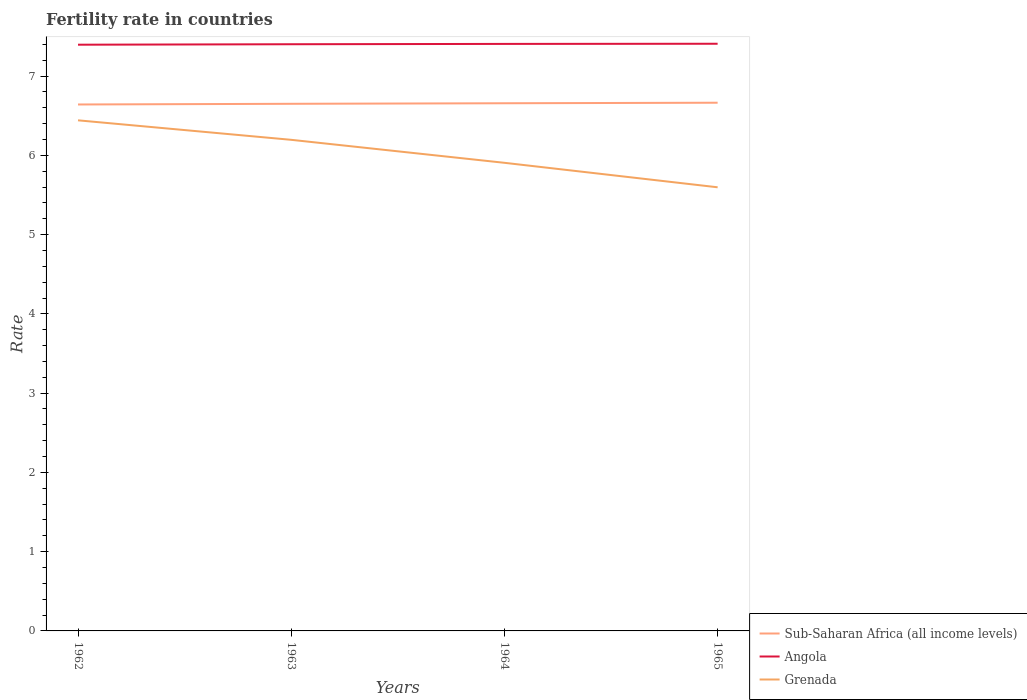Is the number of lines equal to the number of legend labels?
Make the answer very short. Yes. Across all years, what is the maximum fertility rate in Angola?
Offer a terse response. 7.4. In which year was the fertility rate in Angola maximum?
Provide a succinct answer. 1962. What is the total fertility rate in Sub-Saharan Africa (all income levels) in the graph?
Your answer should be compact. -0.01. What is the difference between the highest and the second highest fertility rate in Angola?
Your answer should be compact. 0.01. How many lines are there?
Give a very brief answer. 3. Are the values on the major ticks of Y-axis written in scientific E-notation?
Offer a terse response. No. Where does the legend appear in the graph?
Provide a short and direct response. Bottom right. How many legend labels are there?
Your answer should be compact. 3. How are the legend labels stacked?
Offer a terse response. Vertical. What is the title of the graph?
Give a very brief answer. Fertility rate in countries. Does "Sri Lanka" appear as one of the legend labels in the graph?
Give a very brief answer. No. What is the label or title of the X-axis?
Offer a very short reply. Years. What is the label or title of the Y-axis?
Keep it short and to the point. Rate. What is the Rate in Sub-Saharan Africa (all income levels) in 1962?
Ensure brevity in your answer.  6.64. What is the Rate of Angola in 1962?
Keep it short and to the point. 7.4. What is the Rate of Grenada in 1962?
Keep it short and to the point. 6.44. What is the Rate in Sub-Saharan Africa (all income levels) in 1963?
Provide a succinct answer. 6.65. What is the Rate of Angola in 1963?
Your response must be concise. 7.4. What is the Rate of Grenada in 1963?
Provide a succinct answer. 6.2. What is the Rate in Sub-Saharan Africa (all income levels) in 1964?
Offer a terse response. 6.66. What is the Rate of Angola in 1964?
Keep it short and to the point. 7.41. What is the Rate of Grenada in 1964?
Give a very brief answer. 5.91. What is the Rate in Sub-Saharan Africa (all income levels) in 1965?
Your answer should be very brief. 6.66. What is the Rate in Angola in 1965?
Keep it short and to the point. 7.41. What is the Rate in Grenada in 1965?
Keep it short and to the point. 5.6. Across all years, what is the maximum Rate in Sub-Saharan Africa (all income levels)?
Your answer should be compact. 6.66. Across all years, what is the maximum Rate in Angola?
Provide a short and direct response. 7.41. Across all years, what is the maximum Rate in Grenada?
Your answer should be very brief. 6.44. Across all years, what is the minimum Rate of Sub-Saharan Africa (all income levels)?
Your answer should be compact. 6.64. Across all years, what is the minimum Rate in Angola?
Your response must be concise. 7.4. Across all years, what is the minimum Rate in Grenada?
Your answer should be compact. 5.6. What is the total Rate in Sub-Saharan Africa (all income levels) in the graph?
Your response must be concise. 26.61. What is the total Rate of Angola in the graph?
Provide a short and direct response. 29.61. What is the total Rate in Grenada in the graph?
Provide a succinct answer. 24.14. What is the difference between the Rate of Sub-Saharan Africa (all income levels) in 1962 and that in 1963?
Provide a short and direct response. -0.01. What is the difference between the Rate in Angola in 1962 and that in 1963?
Keep it short and to the point. -0.01. What is the difference between the Rate of Grenada in 1962 and that in 1963?
Your response must be concise. 0.25. What is the difference between the Rate in Sub-Saharan Africa (all income levels) in 1962 and that in 1964?
Your answer should be very brief. -0.02. What is the difference between the Rate in Angola in 1962 and that in 1964?
Provide a short and direct response. -0.01. What is the difference between the Rate in Grenada in 1962 and that in 1964?
Your answer should be very brief. 0.54. What is the difference between the Rate of Sub-Saharan Africa (all income levels) in 1962 and that in 1965?
Your answer should be compact. -0.02. What is the difference between the Rate of Angola in 1962 and that in 1965?
Offer a terse response. -0.01. What is the difference between the Rate of Grenada in 1962 and that in 1965?
Provide a short and direct response. 0.84. What is the difference between the Rate of Sub-Saharan Africa (all income levels) in 1963 and that in 1964?
Give a very brief answer. -0.01. What is the difference between the Rate of Angola in 1963 and that in 1964?
Ensure brevity in your answer.  -0. What is the difference between the Rate of Grenada in 1963 and that in 1964?
Give a very brief answer. 0.29. What is the difference between the Rate in Sub-Saharan Africa (all income levels) in 1963 and that in 1965?
Your answer should be very brief. -0.01. What is the difference between the Rate in Angola in 1963 and that in 1965?
Provide a succinct answer. -0.01. What is the difference between the Rate of Grenada in 1963 and that in 1965?
Give a very brief answer. 0.6. What is the difference between the Rate in Sub-Saharan Africa (all income levels) in 1964 and that in 1965?
Offer a terse response. -0.01. What is the difference between the Rate of Angola in 1964 and that in 1965?
Your answer should be very brief. -0. What is the difference between the Rate in Grenada in 1964 and that in 1965?
Your answer should be compact. 0.31. What is the difference between the Rate in Sub-Saharan Africa (all income levels) in 1962 and the Rate in Angola in 1963?
Your answer should be compact. -0.76. What is the difference between the Rate of Sub-Saharan Africa (all income levels) in 1962 and the Rate of Grenada in 1963?
Your response must be concise. 0.45. What is the difference between the Rate of Angola in 1962 and the Rate of Grenada in 1963?
Provide a succinct answer. 1.2. What is the difference between the Rate of Sub-Saharan Africa (all income levels) in 1962 and the Rate of Angola in 1964?
Provide a succinct answer. -0.76. What is the difference between the Rate of Sub-Saharan Africa (all income levels) in 1962 and the Rate of Grenada in 1964?
Keep it short and to the point. 0.74. What is the difference between the Rate of Angola in 1962 and the Rate of Grenada in 1964?
Give a very brief answer. 1.49. What is the difference between the Rate of Sub-Saharan Africa (all income levels) in 1962 and the Rate of Angola in 1965?
Make the answer very short. -0.77. What is the difference between the Rate in Sub-Saharan Africa (all income levels) in 1962 and the Rate in Grenada in 1965?
Offer a terse response. 1.04. What is the difference between the Rate in Angola in 1962 and the Rate in Grenada in 1965?
Provide a short and direct response. 1.8. What is the difference between the Rate in Sub-Saharan Africa (all income levels) in 1963 and the Rate in Angola in 1964?
Offer a terse response. -0.76. What is the difference between the Rate in Sub-Saharan Africa (all income levels) in 1963 and the Rate in Grenada in 1964?
Offer a terse response. 0.74. What is the difference between the Rate in Angola in 1963 and the Rate in Grenada in 1964?
Offer a very short reply. 1.5. What is the difference between the Rate of Sub-Saharan Africa (all income levels) in 1963 and the Rate of Angola in 1965?
Offer a terse response. -0.76. What is the difference between the Rate in Sub-Saharan Africa (all income levels) in 1963 and the Rate in Grenada in 1965?
Offer a very short reply. 1.05. What is the difference between the Rate in Angola in 1963 and the Rate in Grenada in 1965?
Your answer should be very brief. 1.8. What is the difference between the Rate of Sub-Saharan Africa (all income levels) in 1964 and the Rate of Angola in 1965?
Your response must be concise. -0.75. What is the difference between the Rate in Sub-Saharan Africa (all income levels) in 1964 and the Rate in Grenada in 1965?
Ensure brevity in your answer.  1.06. What is the difference between the Rate in Angola in 1964 and the Rate in Grenada in 1965?
Offer a very short reply. 1.81. What is the average Rate in Sub-Saharan Africa (all income levels) per year?
Provide a succinct answer. 6.65. What is the average Rate in Angola per year?
Ensure brevity in your answer.  7.4. What is the average Rate in Grenada per year?
Provide a succinct answer. 6.04. In the year 1962, what is the difference between the Rate in Sub-Saharan Africa (all income levels) and Rate in Angola?
Keep it short and to the point. -0.75. In the year 1962, what is the difference between the Rate of Sub-Saharan Africa (all income levels) and Rate of Grenada?
Your answer should be compact. 0.2. In the year 1962, what is the difference between the Rate in Angola and Rate in Grenada?
Keep it short and to the point. 0.95. In the year 1963, what is the difference between the Rate of Sub-Saharan Africa (all income levels) and Rate of Angola?
Give a very brief answer. -0.75. In the year 1963, what is the difference between the Rate of Sub-Saharan Africa (all income levels) and Rate of Grenada?
Your response must be concise. 0.45. In the year 1963, what is the difference between the Rate in Angola and Rate in Grenada?
Give a very brief answer. 1.21. In the year 1964, what is the difference between the Rate of Sub-Saharan Africa (all income levels) and Rate of Angola?
Offer a terse response. -0.75. In the year 1964, what is the difference between the Rate in Sub-Saharan Africa (all income levels) and Rate in Grenada?
Give a very brief answer. 0.75. In the year 1964, what is the difference between the Rate in Angola and Rate in Grenada?
Offer a very short reply. 1.5. In the year 1965, what is the difference between the Rate of Sub-Saharan Africa (all income levels) and Rate of Angola?
Ensure brevity in your answer.  -0.74. In the year 1965, what is the difference between the Rate of Sub-Saharan Africa (all income levels) and Rate of Grenada?
Give a very brief answer. 1.07. In the year 1965, what is the difference between the Rate of Angola and Rate of Grenada?
Offer a very short reply. 1.81. What is the ratio of the Rate in Sub-Saharan Africa (all income levels) in 1962 to that in 1963?
Make the answer very short. 1. What is the ratio of the Rate in Angola in 1962 to that in 1963?
Offer a terse response. 1. What is the ratio of the Rate of Grenada in 1962 to that in 1963?
Your response must be concise. 1.04. What is the ratio of the Rate in Sub-Saharan Africa (all income levels) in 1962 to that in 1964?
Your answer should be compact. 1. What is the ratio of the Rate in Angola in 1962 to that in 1964?
Ensure brevity in your answer.  1. What is the ratio of the Rate in Grenada in 1962 to that in 1964?
Offer a terse response. 1.09. What is the ratio of the Rate of Sub-Saharan Africa (all income levels) in 1962 to that in 1965?
Ensure brevity in your answer.  1. What is the ratio of the Rate in Grenada in 1962 to that in 1965?
Offer a very short reply. 1.15. What is the ratio of the Rate in Sub-Saharan Africa (all income levels) in 1963 to that in 1964?
Ensure brevity in your answer.  1. What is the ratio of the Rate of Grenada in 1963 to that in 1964?
Keep it short and to the point. 1.05. What is the ratio of the Rate of Sub-Saharan Africa (all income levels) in 1963 to that in 1965?
Offer a very short reply. 1. What is the ratio of the Rate of Angola in 1963 to that in 1965?
Keep it short and to the point. 1. What is the ratio of the Rate in Grenada in 1963 to that in 1965?
Keep it short and to the point. 1.11. What is the ratio of the Rate in Sub-Saharan Africa (all income levels) in 1964 to that in 1965?
Your answer should be very brief. 1. What is the ratio of the Rate in Angola in 1964 to that in 1965?
Your response must be concise. 1. What is the ratio of the Rate in Grenada in 1964 to that in 1965?
Your response must be concise. 1.06. What is the difference between the highest and the second highest Rate in Sub-Saharan Africa (all income levels)?
Your answer should be compact. 0.01. What is the difference between the highest and the second highest Rate of Angola?
Your answer should be compact. 0. What is the difference between the highest and the second highest Rate of Grenada?
Your answer should be compact. 0.25. What is the difference between the highest and the lowest Rate in Sub-Saharan Africa (all income levels)?
Your answer should be very brief. 0.02. What is the difference between the highest and the lowest Rate of Angola?
Give a very brief answer. 0.01. What is the difference between the highest and the lowest Rate in Grenada?
Offer a terse response. 0.84. 